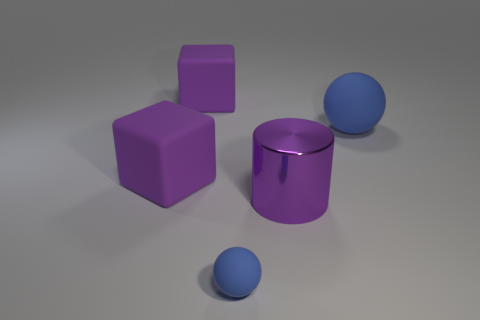Add 5 cylinders. How many objects exist? 10 Subtract all blocks. How many objects are left? 3 Subtract 1 purple cubes. How many objects are left? 4 Subtract all metallic cylinders. Subtract all large purple metallic cylinders. How many objects are left? 3 Add 4 large cylinders. How many large cylinders are left? 5 Add 1 big blue shiny blocks. How many big blue shiny blocks exist? 1 